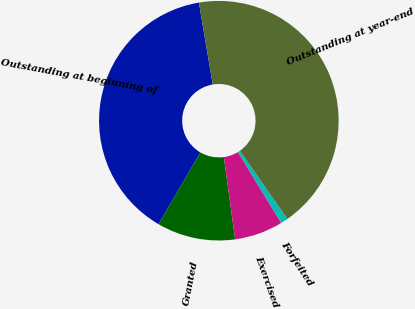<chart> <loc_0><loc_0><loc_500><loc_500><pie_chart><fcel>Outstanding at beginning of<fcel>Granted<fcel>Exercised<fcel>Forfeited<fcel>Outstanding at year-end<nl><fcel>38.95%<fcel>10.56%<fcel>6.54%<fcel>0.99%<fcel>42.96%<nl></chart> 